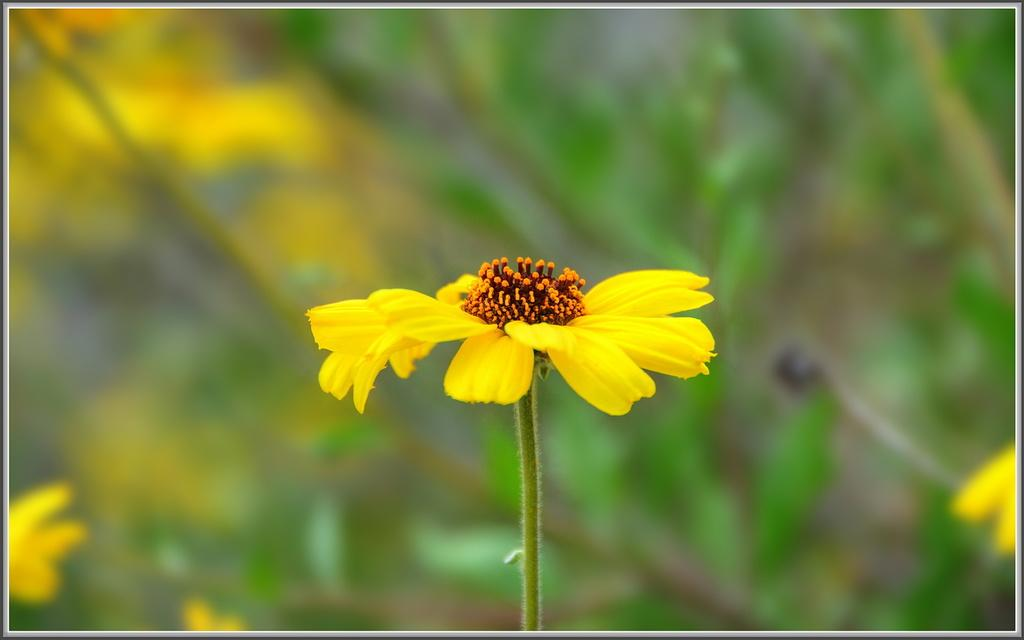What type of flower is in the image? There is a yellow flower in the image. What is the color of the buds on the flower? The buds on the flower are orange in color. How would you describe the background of the image? The background of the image is blurred. What colors can be seen in the background of the image? Green and yellow colors are visible in the background. Who is the creator of the soap depicted in the image? There is no soap present in the image, so it is not possible to determine the creator. 